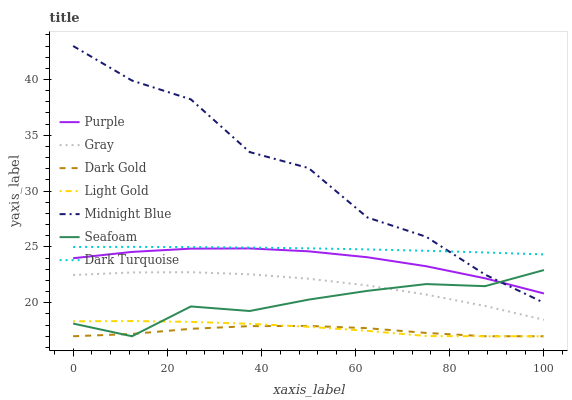Does Dark Gold have the minimum area under the curve?
Answer yes or no. Yes. Does Midnight Blue have the maximum area under the curve?
Answer yes or no. Yes. Does Midnight Blue have the minimum area under the curve?
Answer yes or no. No. Does Dark Gold have the maximum area under the curve?
Answer yes or no. No. Is Dark Turquoise the smoothest?
Answer yes or no. Yes. Is Midnight Blue the roughest?
Answer yes or no. Yes. Is Dark Gold the smoothest?
Answer yes or no. No. Is Dark Gold the roughest?
Answer yes or no. No. Does Midnight Blue have the lowest value?
Answer yes or no. No. Does Midnight Blue have the highest value?
Answer yes or no. Yes. Does Dark Gold have the highest value?
Answer yes or no. No. Is Purple less than Dark Turquoise?
Answer yes or no. Yes. Is Midnight Blue greater than Light Gold?
Answer yes or no. Yes. Does Purple intersect Dark Turquoise?
Answer yes or no. No. 